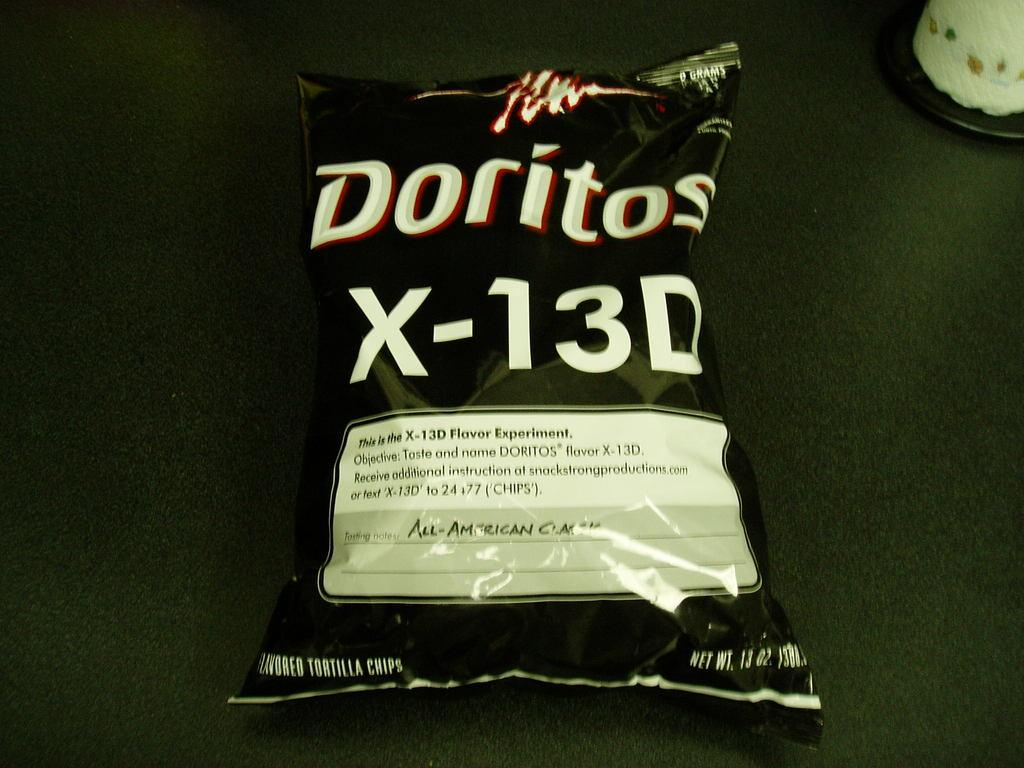<image>
Offer a succinct explanation of the picture presented. A green and white of x-13D Doritos laying on green material. 